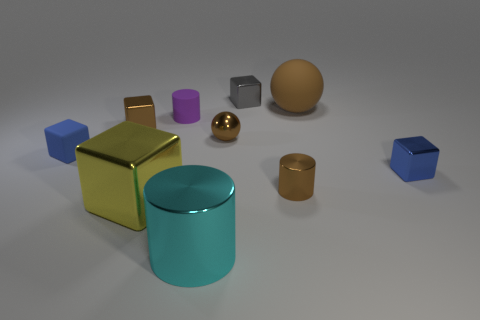Does the tiny sphere have the same color as the matte sphere?
Keep it short and to the point. Yes. How many rubber things are either large balls or red cylinders?
Make the answer very short. 1. How many tiny blue metal blocks are there?
Ensure brevity in your answer.  1. Is the cylinder behind the matte cube made of the same material as the cube that is behind the tiny purple object?
Ensure brevity in your answer.  No. The big shiny object that is the same shape as the small purple matte thing is what color?
Ensure brevity in your answer.  Cyan. What is the material of the tiny blue object that is right of the large object that is behind the purple object?
Your answer should be very brief. Metal. There is a tiny blue thing that is on the left side of the small purple rubber object; is it the same shape as the small blue thing that is right of the matte ball?
Your answer should be very brief. Yes. What size is the rubber object that is both on the left side of the tiny gray metallic cube and right of the small matte cube?
Provide a short and direct response. Small. How many other objects are the same color as the large metal cylinder?
Offer a terse response. 0. Are there an equal number of tiny gray objects and small brown rubber objects?
Provide a succinct answer. No. 